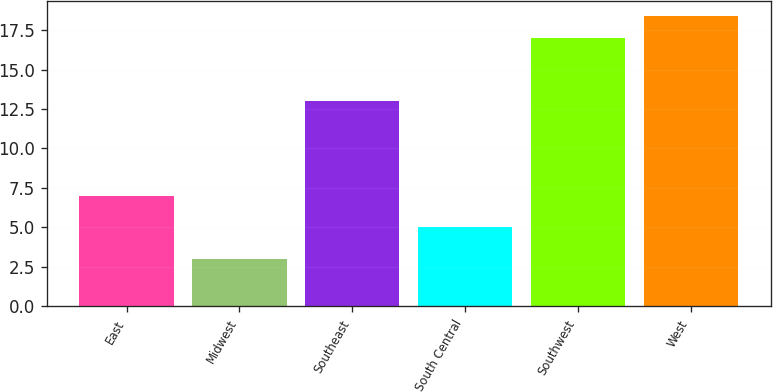Convert chart to OTSL. <chart><loc_0><loc_0><loc_500><loc_500><bar_chart><fcel>East<fcel>Midwest<fcel>Southeast<fcel>South Central<fcel>Southwest<fcel>West<nl><fcel>7<fcel>3<fcel>13<fcel>5<fcel>17<fcel>18.4<nl></chart> 